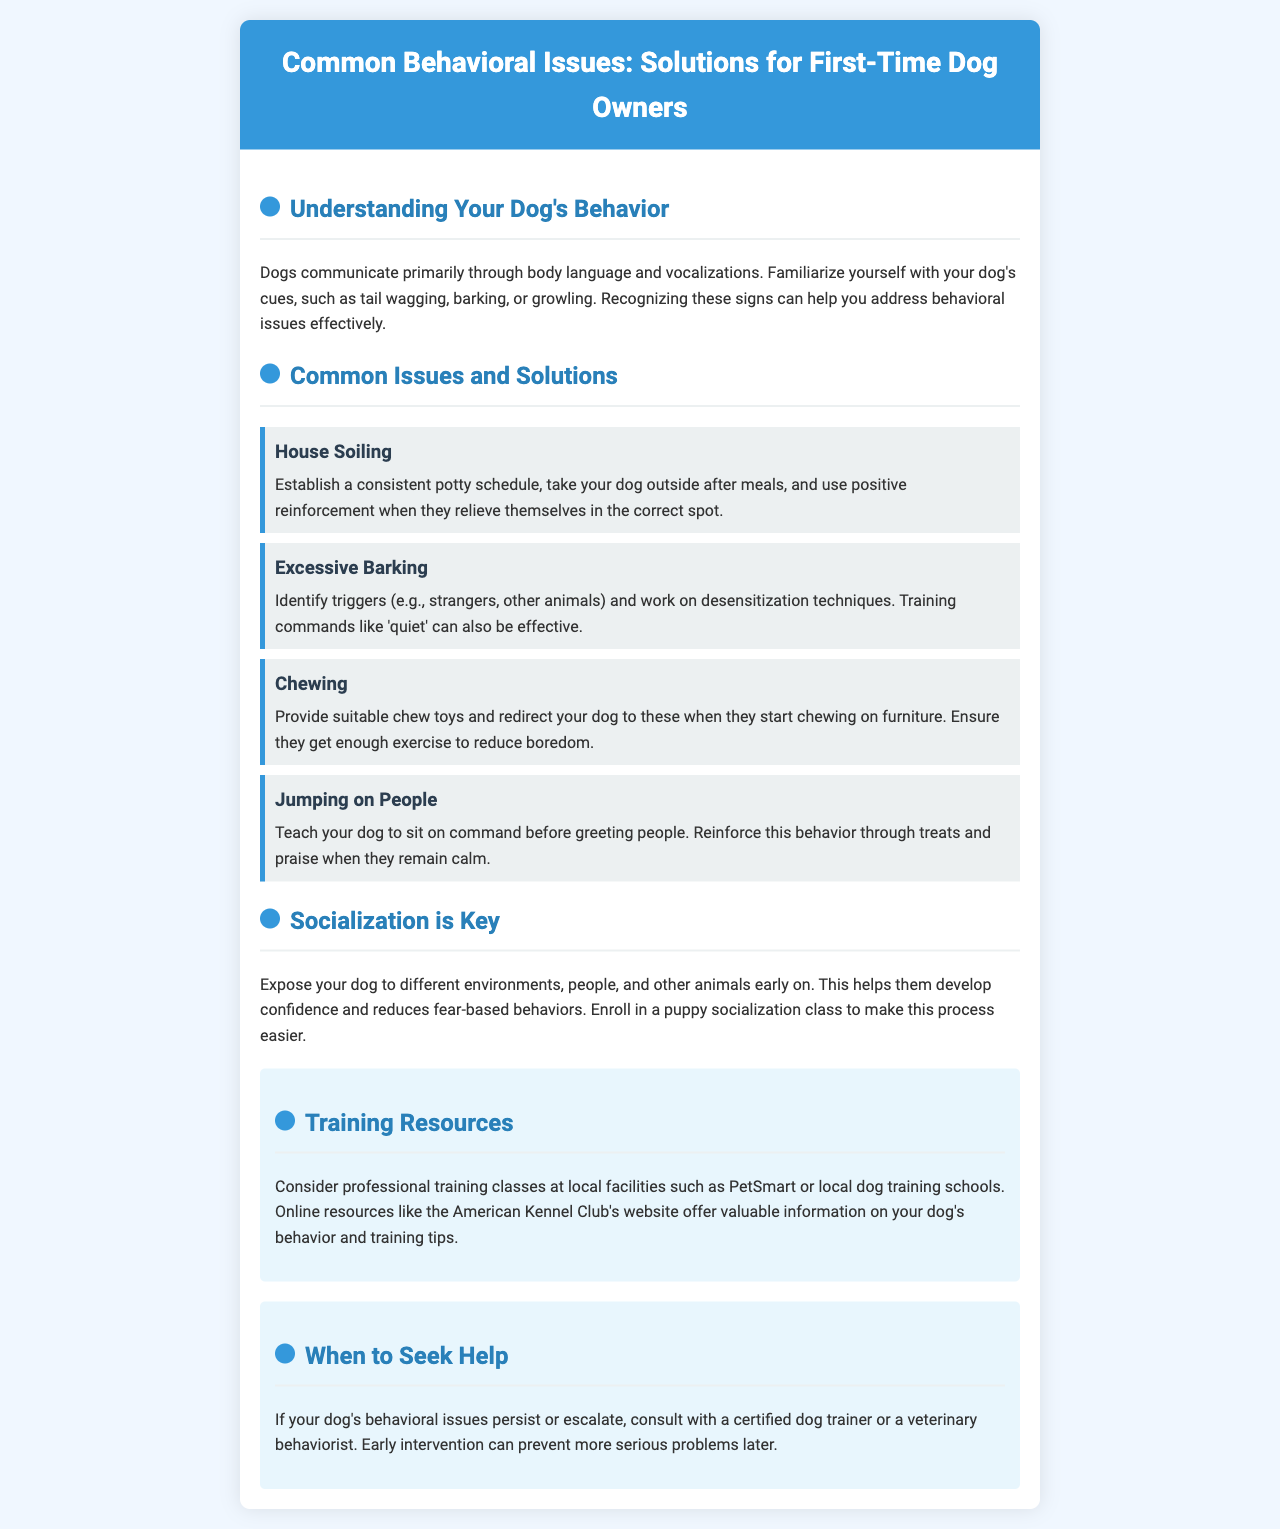What is the title of the brochure? The title of the brochure is stated at the top of the document, which introduces the content specifically for first-time dog owners.
Answer: Common Behavioral Issues: Solutions for First-Time Dog Owners What is one method to address house soiling? The document provides a specific solution in the section about house soiling.
Answer: Establish a consistent potty schedule What should you provide to prevent your dog from chewing furniture? The brochure recommends a solution for excessive chewing, which is covered in a specific issue section.
Answer: Suitable chew toys What command can help manage excessive barking? The document suggests a specific command that can be helpful to control barking in dogs.
Answer: Quiet What should you do if behavioral issues persist? The brochure indicates a course of action when faced with ongoing issues, emphasizing the importance of professional help.
Answer: Consult with a certified dog trainer How does the brochure suggest improving socialization? The document describes actions that enhance socialization for dogs, which is presented in a dedicated section.
Answer: Enroll in a puppy socialization class What color is the header of the brochure? The visual design element is mentioned in the document, specifically focusing on how the header is styled.
Answer: Blue What aspect is emphasized in "Understanding Your Dog's Behavior"? The brochure addresses a crucial communication aspect in this section.
Answer: Body language and vocalizations How can a dog owner reinforce calm behavior when greeting people? The document details a method that owners can use to reinforce desired behavior through interaction.
Answer: Treats and praise 